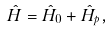Convert formula to latex. <formula><loc_0><loc_0><loc_500><loc_500>\hat { H } = \hat { H } _ { 0 } + \hat { H } _ { p } ,</formula> 